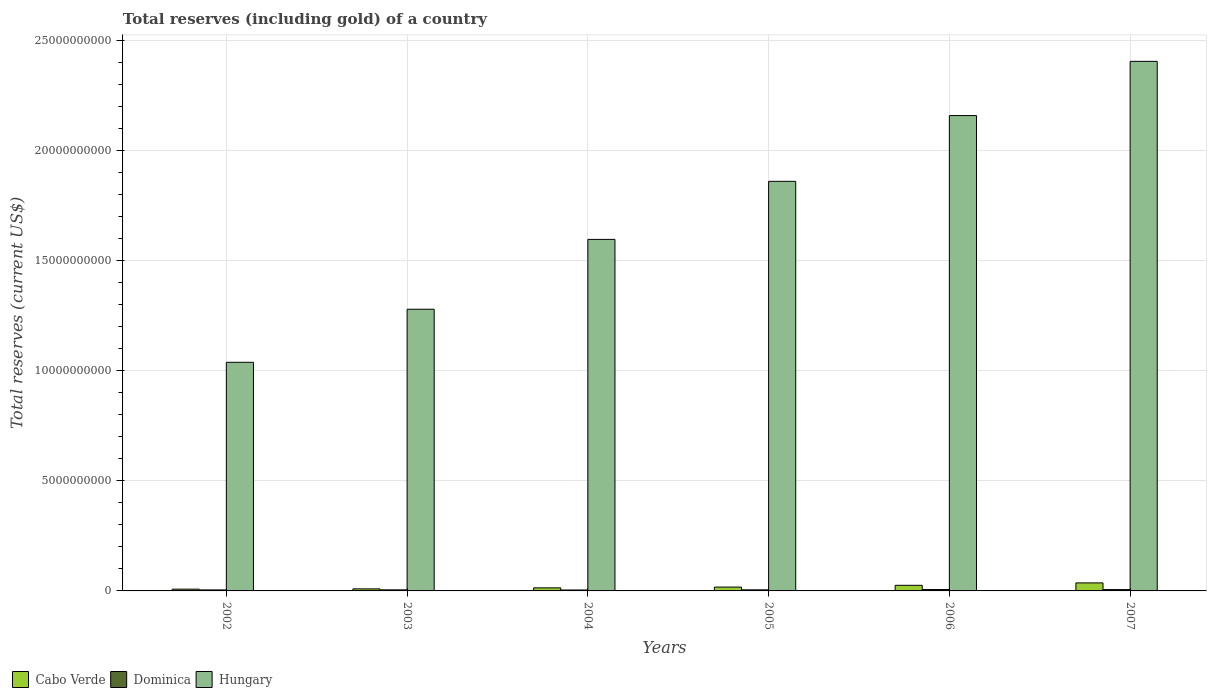Are the number of bars on each tick of the X-axis equal?
Your answer should be very brief. Yes. How many bars are there on the 1st tick from the left?
Offer a very short reply. 3. What is the label of the 4th group of bars from the left?
Ensure brevity in your answer.  2005. What is the total reserves (including gold) in Dominica in 2006?
Keep it short and to the point. 6.30e+07. Across all years, what is the maximum total reserves (including gold) in Dominica?
Your answer should be compact. 6.30e+07. Across all years, what is the minimum total reserves (including gold) in Dominica?
Make the answer very short. 4.23e+07. What is the total total reserves (including gold) in Dominica in the graph?
Offer a very short reply. 3.08e+08. What is the difference between the total reserves (including gold) in Dominica in 2002 and that in 2005?
Make the answer very short. -3.67e+06. What is the difference between the total reserves (including gold) in Cabo Verde in 2005 and the total reserves (including gold) in Dominica in 2002?
Offer a terse response. 1.28e+08. What is the average total reserves (including gold) in Cabo Verde per year?
Make the answer very short. 1.84e+08. In the year 2002, what is the difference between the total reserves (including gold) in Cabo Verde and total reserves (including gold) in Hungary?
Your response must be concise. -1.03e+1. What is the ratio of the total reserves (including gold) in Dominica in 2002 to that in 2005?
Ensure brevity in your answer.  0.93. Is the total reserves (including gold) in Dominica in 2002 less than that in 2005?
Your response must be concise. Yes. What is the difference between the highest and the second highest total reserves (including gold) in Cabo Verde?
Make the answer very short. 1.10e+08. What is the difference between the highest and the lowest total reserves (including gold) in Dominica?
Give a very brief answer. 2.07e+07. Is the sum of the total reserves (including gold) in Cabo Verde in 2002 and 2005 greater than the maximum total reserves (including gold) in Hungary across all years?
Keep it short and to the point. No. What does the 3rd bar from the left in 2005 represents?
Offer a very short reply. Hungary. What does the 2nd bar from the right in 2002 represents?
Keep it short and to the point. Dominica. Is it the case that in every year, the sum of the total reserves (including gold) in Cabo Verde and total reserves (including gold) in Hungary is greater than the total reserves (including gold) in Dominica?
Provide a short and direct response. Yes. How many bars are there?
Make the answer very short. 18. Are all the bars in the graph horizontal?
Offer a terse response. No. Are the values on the major ticks of Y-axis written in scientific E-notation?
Make the answer very short. No. How are the legend labels stacked?
Offer a very short reply. Horizontal. What is the title of the graph?
Give a very brief answer. Total reserves (including gold) of a country. What is the label or title of the X-axis?
Give a very brief answer. Years. What is the label or title of the Y-axis?
Make the answer very short. Total reserves (current US$). What is the Total reserves (current US$) in Cabo Verde in 2002?
Provide a short and direct response. 7.98e+07. What is the Total reserves (current US$) in Dominica in 2002?
Provide a short and direct response. 4.55e+07. What is the Total reserves (current US$) in Hungary in 2002?
Offer a very short reply. 1.04e+1. What is the Total reserves (current US$) in Cabo Verde in 2003?
Your answer should be very brief. 9.36e+07. What is the Total reserves (current US$) of Dominica in 2003?
Your answer should be compact. 4.77e+07. What is the Total reserves (current US$) of Hungary in 2003?
Provide a short and direct response. 1.28e+1. What is the Total reserves (current US$) of Cabo Verde in 2004?
Offer a terse response. 1.40e+08. What is the Total reserves (current US$) of Dominica in 2004?
Offer a very short reply. 4.23e+07. What is the Total reserves (current US$) of Hungary in 2004?
Your answer should be very brief. 1.60e+1. What is the Total reserves (current US$) in Cabo Verde in 2005?
Provide a short and direct response. 1.74e+08. What is the Total reserves (current US$) in Dominica in 2005?
Provide a short and direct response. 4.92e+07. What is the Total reserves (current US$) in Hungary in 2005?
Give a very brief answer. 1.86e+1. What is the Total reserves (current US$) in Cabo Verde in 2006?
Offer a terse response. 2.54e+08. What is the Total reserves (current US$) in Dominica in 2006?
Offer a very short reply. 6.30e+07. What is the Total reserves (current US$) of Hungary in 2006?
Ensure brevity in your answer.  2.16e+1. What is the Total reserves (current US$) in Cabo Verde in 2007?
Your response must be concise. 3.64e+08. What is the Total reserves (current US$) in Dominica in 2007?
Make the answer very short. 6.05e+07. What is the Total reserves (current US$) in Hungary in 2007?
Your answer should be compact. 2.41e+1. Across all years, what is the maximum Total reserves (current US$) of Cabo Verde?
Your response must be concise. 3.64e+08. Across all years, what is the maximum Total reserves (current US$) in Dominica?
Provide a succinct answer. 6.30e+07. Across all years, what is the maximum Total reserves (current US$) of Hungary?
Your answer should be compact. 2.41e+1. Across all years, what is the minimum Total reserves (current US$) of Cabo Verde?
Give a very brief answer. 7.98e+07. Across all years, what is the minimum Total reserves (current US$) in Dominica?
Make the answer very short. 4.23e+07. Across all years, what is the minimum Total reserves (current US$) in Hungary?
Your answer should be very brief. 1.04e+1. What is the total Total reserves (current US$) of Cabo Verde in the graph?
Make the answer very short. 1.11e+09. What is the total Total reserves (current US$) in Dominica in the graph?
Give a very brief answer. 3.08e+08. What is the total Total reserves (current US$) in Hungary in the graph?
Your answer should be compact. 1.03e+11. What is the difference between the Total reserves (current US$) in Cabo Verde in 2002 and that in 2003?
Provide a short and direct response. -1.38e+07. What is the difference between the Total reserves (current US$) of Dominica in 2002 and that in 2003?
Keep it short and to the point. -2.24e+06. What is the difference between the Total reserves (current US$) in Hungary in 2002 and that in 2003?
Offer a terse response. -2.41e+09. What is the difference between the Total reserves (current US$) in Cabo Verde in 2002 and that in 2004?
Ensure brevity in your answer.  -5.97e+07. What is the difference between the Total reserves (current US$) in Dominica in 2002 and that in 2004?
Make the answer very short. 3.18e+06. What is the difference between the Total reserves (current US$) of Hungary in 2002 and that in 2004?
Keep it short and to the point. -5.58e+09. What is the difference between the Total reserves (current US$) of Cabo Verde in 2002 and that in 2005?
Your answer should be very brief. -9.42e+07. What is the difference between the Total reserves (current US$) in Dominica in 2002 and that in 2005?
Offer a very short reply. -3.67e+06. What is the difference between the Total reserves (current US$) of Hungary in 2002 and that in 2005?
Ensure brevity in your answer.  -8.22e+09. What is the difference between the Total reserves (current US$) in Cabo Verde in 2002 and that in 2006?
Keep it short and to the point. -1.75e+08. What is the difference between the Total reserves (current US$) in Dominica in 2002 and that in 2006?
Offer a very short reply. -1.75e+07. What is the difference between the Total reserves (current US$) of Hungary in 2002 and that in 2006?
Provide a succinct answer. -1.12e+1. What is the difference between the Total reserves (current US$) of Cabo Verde in 2002 and that in 2007?
Offer a terse response. -2.85e+08. What is the difference between the Total reserves (current US$) in Dominica in 2002 and that in 2007?
Give a very brief answer. -1.50e+07. What is the difference between the Total reserves (current US$) of Hungary in 2002 and that in 2007?
Give a very brief answer. -1.37e+1. What is the difference between the Total reserves (current US$) of Cabo Verde in 2003 and that in 2004?
Provide a succinct answer. -4.59e+07. What is the difference between the Total reserves (current US$) in Dominica in 2003 and that in 2004?
Provide a short and direct response. 5.41e+06. What is the difference between the Total reserves (current US$) in Hungary in 2003 and that in 2004?
Give a very brief answer. -3.17e+09. What is the difference between the Total reserves (current US$) of Cabo Verde in 2003 and that in 2005?
Ensure brevity in your answer.  -8.04e+07. What is the difference between the Total reserves (current US$) of Dominica in 2003 and that in 2005?
Your response must be concise. -1.44e+06. What is the difference between the Total reserves (current US$) of Hungary in 2003 and that in 2005?
Your answer should be very brief. -5.81e+09. What is the difference between the Total reserves (current US$) of Cabo Verde in 2003 and that in 2006?
Ensure brevity in your answer.  -1.61e+08. What is the difference between the Total reserves (current US$) of Dominica in 2003 and that in 2006?
Your response must be concise. -1.53e+07. What is the difference between the Total reserves (current US$) in Hungary in 2003 and that in 2006?
Your answer should be very brief. -8.80e+09. What is the difference between the Total reserves (current US$) of Cabo Verde in 2003 and that in 2007?
Your answer should be compact. -2.71e+08. What is the difference between the Total reserves (current US$) of Dominica in 2003 and that in 2007?
Keep it short and to the point. -1.28e+07. What is the difference between the Total reserves (current US$) in Hungary in 2003 and that in 2007?
Ensure brevity in your answer.  -1.13e+1. What is the difference between the Total reserves (current US$) in Cabo Verde in 2004 and that in 2005?
Make the answer very short. -3.44e+07. What is the difference between the Total reserves (current US$) in Dominica in 2004 and that in 2005?
Your answer should be compact. -6.85e+06. What is the difference between the Total reserves (current US$) of Hungary in 2004 and that in 2005?
Your response must be concise. -2.64e+09. What is the difference between the Total reserves (current US$) of Cabo Verde in 2004 and that in 2006?
Make the answer very short. -1.15e+08. What is the difference between the Total reserves (current US$) of Dominica in 2004 and that in 2006?
Offer a terse response. -2.07e+07. What is the difference between the Total reserves (current US$) in Hungary in 2004 and that in 2006?
Provide a short and direct response. -5.62e+09. What is the difference between the Total reserves (current US$) of Cabo Verde in 2004 and that in 2007?
Your answer should be compact. -2.25e+08. What is the difference between the Total reserves (current US$) in Dominica in 2004 and that in 2007?
Provide a succinct answer. -1.82e+07. What is the difference between the Total reserves (current US$) in Hungary in 2004 and that in 2007?
Ensure brevity in your answer.  -8.09e+09. What is the difference between the Total reserves (current US$) of Cabo Verde in 2005 and that in 2006?
Keep it short and to the point. -8.05e+07. What is the difference between the Total reserves (current US$) in Dominica in 2005 and that in 2006?
Give a very brief answer. -1.39e+07. What is the difference between the Total reserves (current US$) of Hungary in 2005 and that in 2006?
Provide a short and direct response. -2.99e+09. What is the difference between the Total reserves (current US$) in Cabo Verde in 2005 and that in 2007?
Provide a short and direct response. -1.90e+08. What is the difference between the Total reserves (current US$) of Dominica in 2005 and that in 2007?
Make the answer very short. -1.13e+07. What is the difference between the Total reserves (current US$) of Hungary in 2005 and that in 2007?
Make the answer very short. -5.45e+09. What is the difference between the Total reserves (current US$) of Cabo Verde in 2006 and that in 2007?
Your response must be concise. -1.10e+08. What is the difference between the Total reserves (current US$) in Dominica in 2006 and that in 2007?
Your answer should be compact. 2.53e+06. What is the difference between the Total reserves (current US$) of Hungary in 2006 and that in 2007?
Offer a terse response. -2.46e+09. What is the difference between the Total reserves (current US$) in Cabo Verde in 2002 and the Total reserves (current US$) in Dominica in 2003?
Keep it short and to the point. 3.21e+07. What is the difference between the Total reserves (current US$) of Cabo Verde in 2002 and the Total reserves (current US$) of Hungary in 2003?
Your response must be concise. -1.27e+1. What is the difference between the Total reserves (current US$) in Dominica in 2002 and the Total reserves (current US$) in Hungary in 2003?
Your answer should be very brief. -1.27e+1. What is the difference between the Total reserves (current US$) in Cabo Verde in 2002 and the Total reserves (current US$) in Dominica in 2004?
Make the answer very short. 3.75e+07. What is the difference between the Total reserves (current US$) in Cabo Verde in 2002 and the Total reserves (current US$) in Hungary in 2004?
Your response must be concise. -1.59e+1. What is the difference between the Total reserves (current US$) of Dominica in 2002 and the Total reserves (current US$) of Hungary in 2004?
Provide a short and direct response. -1.59e+1. What is the difference between the Total reserves (current US$) of Cabo Verde in 2002 and the Total reserves (current US$) of Dominica in 2005?
Offer a very short reply. 3.06e+07. What is the difference between the Total reserves (current US$) in Cabo Verde in 2002 and the Total reserves (current US$) in Hungary in 2005?
Ensure brevity in your answer.  -1.85e+1. What is the difference between the Total reserves (current US$) of Dominica in 2002 and the Total reserves (current US$) of Hungary in 2005?
Offer a very short reply. -1.86e+1. What is the difference between the Total reserves (current US$) of Cabo Verde in 2002 and the Total reserves (current US$) of Dominica in 2006?
Your response must be concise. 1.68e+07. What is the difference between the Total reserves (current US$) in Cabo Verde in 2002 and the Total reserves (current US$) in Hungary in 2006?
Your response must be concise. -2.15e+1. What is the difference between the Total reserves (current US$) of Dominica in 2002 and the Total reserves (current US$) of Hungary in 2006?
Keep it short and to the point. -2.15e+1. What is the difference between the Total reserves (current US$) in Cabo Verde in 2002 and the Total reserves (current US$) in Dominica in 2007?
Your answer should be compact. 1.93e+07. What is the difference between the Total reserves (current US$) in Cabo Verde in 2002 and the Total reserves (current US$) in Hungary in 2007?
Give a very brief answer. -2.40e+1. What is the difference between the Total reserves (current US$) of Dominica in 2002 and the Total reserves (current US$) of Hungary in 2007?
Provide a succinct answer. -2.40e+1. What is the difference between the Total reserves (current US$) of Cabo Verde in 2003 and the Total reserves (current US$) of Dominica in 2004?
Keep it short and to the point. 5.13e+07. What is the difference between the Total reserves (current US$) in Cabo Verde in 2003 and the Total reserves (current US$) in Hungary in 2004?
Keep it short and to the point. -1.59e+1. What is the difference between the Total reserves (current US$) in Dominica in 2003 and the Total reserves (current US$) in Hungary in 2004?
Ensure brevity in your answer.  -1.59e+1. What is the difference between the Total reserves (current US$) of Cabo Verde in 2003 and the Total reserves (current US$) of Dominica in 2005?
Make the answer very short. 4.44e+07. What is the difference between the Total reserves (current US$) of Cabo Verde in 2003 and the Total reserves (current US$) of Hungary in 2005?
Your response must be concise. -1.85e+1. What is the difference between the Total reserves (current US$) of Dominica in 2003 and the Total reserves (current US$) of Hungary in 2005?
Offer a terse response. -1.86e+1. What is the difference between the Total reserves (current US$) in Cabo Verde in 2003 and the Total reserves (current US$) in Dominica in 2006?
Keep it short and to the point. 3.06e+07. What is the difference between the Total reserves (current US$) of Cabo Verde in 2003 and the Total reserves (current US$) of Hungary in 2006?
Ensure brevity in your answer.  -2.15e+1. What is the difference between the Total reserves (current US$) in Dominica in 2003 and the Total reserves (current US$) in Hungary in 2006?
Your answer should be very brief. -2.15e+1. What is the difference between the Total reserves (current US$) in Cabo Verde in 2003 and the Total reserves (current US$) in Dominica in 2007?
Provide a short and direct response. 3.31e+07. What is the difference between the Total reserves (current US$) in Cabo Verde in 2003 and the Total reserves (current US$) in Hungary in 2007?
Your answer should be very brief. -2.40e+1. What is the difference between the Total reserves (current US$) of Dominica in 2003 and the Total reserves (current US$) of Hungary in 2007?
Your answer should be very brief. -2.40e+1. What is the difference between the Total reserves (current US$) of Cabo Verde in 2004 and the Total reserves (current US$) of Dominica in 2005?
Provide a succinct answer. 9.04e+07. What is the difference between the Total reserves (current US$) of Cabo Verde in 2004 and the Total reserves (current US$) of Hungary in 2005?
Ensure brevity in your answer.  -1.85e+1. What is the difference between the Total reserves (current US$) of Dominica in 2004 and the Total reserves (current US$) of Hungary in 2005?
Give a very brief answer. -1.86e+1. What is the difference between the Total reserves (current US$) in Cabo Verde in 2004 and the Total reserves (current US$) in Dominica in 2006?
Your answer should be very brief. 7.65e+07. What is the difference between the Total reserves (current US$) of Cabo Verde in 2004 and the Total reserves (current US$) of Hungary in 2006?
Offer a terse response. -2.15e+1. What is the difference between the Total reserves (current US$) in Dominica in 2004 and the Total reserves (current US$) in Hungary in 2006?
Offer a terse response. -2.15e+1. What is the difference between the Total reserves (current US$) of Cabo Verde in 2004 and the Total reserves (current US$) of Dominica in 2007?
Give a very brief answer. 7.90e+07. What is the difference between the Total reserves (current US$) in Cabo Verde in 2004 and the Total reserves (current US$) in Hungary in 2007?
Keep it short and to the point. -2.39e+1. What is the difference between the Total reserves (current US$) in Dominica in 2004 and the Total reserves (current US$) in Hungary in 2007?
Keep it short and to the point. -2.40e+1. What is the difference between the Total reserves (current US$) of Cabo Verde in 2005 and the Total reserves (current US$) of Dominica in 2006?
Offer a terse response. 1.11e+08. What is the difference between the Total reserves (current US$) in Cabo Verde in 2005 and the Total reserves (current US$) in Hungary in 2006?
Ensure brevity in your answer.  -2.14e+1. What is the difference between the Total reserves (current US$) in Dominica in 2005 and the Total reserves (current US$) in Hungary in 2006?
Offer a very short reply. -2.15e+1. What is the difference between the Total reserves (current US$) in Cabo Verde in 2005 and the Total reserves (current US$) in Dominica in 2007?
Offer a terse response. 1.13e+08. What is the difference between the Total reserves (current US$) in Cabo Verde in 2005 and the Total reserves (current US$) in Hungary in 2007?
Your answer should be very brief. -2.39e+1. What is the difference between the Total reserves (current US$) in Dominica in 2005 and the Total reserves (current US$) in Hungary in 2007?
Provide a short and direct response. -2.40e+1. What is the difference between the Total reserves (current US$) of Cabo Verde in 2006 and the Total reserves (current US$) of Dominica in 2007?
Make the answer very short. 1.94e+08. What is the difference between the Total reserves (current US$) in Cabo Verde in 2006 and the Total reserves (current US$) in Hungary in 2007?
Your response must be concise. -2.38e+1. What is the difference between the Total reserves (current US$) of Dominica in 2006 and the Total reserves (current US$) of Hungary in 2007?
Your answer should be compact. -2.40e+1. What is the average Total reserves (current US$) of Cabo Verde per year?
Offer a very short reply. 1.84e+08. What is the average Total reserves (current US$) of Dominica per year?
Provide a succinct answer. 5.14e+07. What is the average Total reserves (current US$) in Hungary per year?
Offer a very short reply. 1.72e+1. In the year 2002, what is the difference between the Total reserves (current US$) of Cabo Verde and Total reserves (current US$) of Dominica?
Keep it short and to the point. 3.43e+07. In the year 2002, what is the difference between the Total reserves (current US$) of Cabo Verde and Total reserves (current US$) of Hungary?
Your answer should be very brief. -1.03e+1. In the year 2002, what is the difference between the Total reserves (current US$) in Dominica and Total reserves (current US$) in Hungary?
Offer a very short reply. -1.03e+1. In the year 2003, what is the difference between the Total reserves (current US$) of Cabo Verde and Total reserves (current US$) of Dominica?
Make the answer very short. 4.59e+07. In the year 2003, what is the difference between the Total reserves (current US$) of Cabo Verde and Total reserves (current US$) of Hungary?
Ensure brevity in your answer.  -1.27e+1. In the year 2003, what is the difference between the Total reserves (current US$) in Dominica and Total reserves (current US$) in Hungary?
Your response must be concise. -1.27e+1. In the year 2004, what is the difference between the Total reserves (current US$) of Cabo Verde and Total reserves (current US$) of Dominica?
Give a very brief answer. 9.72e+07. In the year 2004, what is the difference between the Total reserves (current US$) of Cabo Verde and Total reserves (current US$) of Hungary?
Offer a terse response. -1.58e+1. In the year 2004, what is the difference between the Total reserves (current US$) of Dominica and Total reserves (current US$) of Hungary?
Make the answer very short. -1.59e+1. In the year 2005, what is the difference between the Total reserves (current US$) of Cabo Verde and Total reserves (current US$) of Dominica?
Provide a short and direct response. 1.25e+08. In the year 2005, what is the difference between the Total reserves (current US$) of Cabo Verde and Total reserves (current US$) of Hungary?
Offer a very short reply. -1.84e+1. In the year 2005, what is the difference between the Total reserves (current US$) in Dominica and Total reserves (current US$) in Hungary?
Offer a terse response. -1.86e+1. In the year 2006, what is the difference between the Total reserves (current US$) of Cabo Verde and Total reserves (current US$) of Dominica?
Make the answer very short. 1.91e+08. In the year 2006, what is the difference between the Total reserves (current US$) of Cabo Verde and Total reserves (current US$) of Hungary?
Your answer should be compact. -2.13e+1. In the year 2006, what is the difference between the Total reserves (current US$) in Dominica and Total reserves (current US$) in Hungary?
Provide a short and direct response. -2.15e+1. In the year 2007, what is the difference between the Total reserves (current US$) in Cabo Verde and Total reserves (current US$) in Dominica?
Your answer should be very brief. 3.04e+08. In the year 2007, what is the difference between the Total reserves (current US$) of Cabo Verde and Total reserves (current US$) of Hungary?
Your answer should be compact. -2.37e+1. In the year 2007, what is the difference between the Total reserves (current US$) in Dominica and Total reserves (current US$) in Hungary?
Offer a very short reply. -2.40e+1. What is the ratio of the Total reserves (current US$) of Cabo Verde in 2002 to that in 2003?
Your answer should be compact. 0.85. What is the ratio of the Total reserves (current US$) in Dominica in 2002 to that in 2003?
Keep it short and to the point. 0.95. What is the ratio of the Total reserves (current US$) of Hungary in 2002 to that in 2003?
Offer a terse response. 0.81. What is the ratio of the Total reserves (current US$) in Cabo Verde in 2002 to that in 2004?
Provide a short and direct response. 0.57. What is the ratio of the Total reserves (current US$) of Dominica in 2002 to that in 2004?
Ensure brevity in your answer.  1.07. What is the ratio of the Total reserves (current US$) in Hungary in 2002 to that in 2004?
Your answer should be very brief. 0.65. What is the ratio of the Total reserves (current US$) of Cabo Verde in 2002 to that in 2005?
Provide a succinct answer. 0.46. What is the ratio of the Total reserves (current US$) of Dominica in 2002 to that in 2005?
Provide a succinct answer. 0.93. What is the ratio of the Total reserves (current US$) in Hungary in 2002 to that in 2005?
Make the answer very short. 0.56. What is the ratio of the Total reserves (current US$) of Cabo Verde in 2002 to that in 2006?
Ensure brevity in your answer.  0.31. What is the ratio of the Total reserves (current US$) of Dominica in 2002 to that in 2006?
Offer a terse response. 0.72. What is the ratio of the Total reserves (current US$) in Hungary in 2002 to that in 2006?
Make the answer very short. 0.48. What is the ratio of the Total reserves (current US$) in Cabo Verde in 2002 to that in 2007?
Provide a short and direct response. 0.22. What is the ratio of the Total reserves (current US$) in Dominica in 2002 to that in 2007?
Give a very brief answer. 0.75. What is the ratio of the Total reserves (current US$) of Hungary in 2002 to that in 2007?
Your response must be concise. 0.43. What is the ratio of the Total reserves (current US$) in Cabo Verde in 2003 to that in 2004?
Provide a short and direct response. 0.67. What is the ratio of the Total reserves (current US$) of Dominica in 2003 to that in 2004?
Give a very brief answer. 1.13. What is the ratio of the Total reserves (current US$) in Hungary in 2003 to that in 2004?
Offer a terse response. 0.8. What is the ratio of the Total reserves (current US$) in Cabo Verde in 2003 to that in 2005?
Offer a terse response. 0.54. What is the ratio of the Total reserves (current US$) in Dominica in 2003 to that in 2005?
Offer a very short reply. 0.97. What is the ratio of the Total reserves (current US$) in Hungary in 2003 to that in 2005?
Offer a very short reply. 0.69. What is the ratio of the Total reserves (current US$) in Cabo Verde in 2003 to that in 2006?
Give a very brief answer. 0.37. What is the ratio of the Total reserves (current US$) in Dominica in 2003 to that in 2006?
Provide a succinct answer. 0.76. What is the ratio of the Total reserves (current US$) in Hungary in 2003 to that in 2006?
Provide a succinct answer. 0.59. What is the ratio of the Total reserves (current US$) of Cabo Verde in 2003 to that in 2007?
Make the answer very short. 0.26. What is the ratio of the Total reserves (current US$) in Dominica in 2003 to that in 2007?
Your answer should be compact. 0.79. What is the ratio of the Total reserves (current US$) in Hungary in 2003 to that in 2007?
Offer a very short reply. 0.53. What is the ratio of the Total reserves (current US$) in Cabo Verde in 2004 to that in 2005?
Give a very brief answer. 0.8. What is the ratio of the Total reserves (current US$) of Dominica in 2004 to that in 2005?
Keep it short and to the point. 0.86. What is the ratio of the Total reserves (current US$) in Hungary in 2004 to that in 2005?
Your response must be concise. 0.86. What is the ratio of the Total reserves (current US$) in Cabo Verde in 2004 to that in 2006?
Your response must be concise. 0.55. What is the ratio of the Total reserves (current US$) of Dominica in 2004 to that in 2006?
Ensure brevity in your answer.  0.67. What is the ratio of the Total reserves (current US$) in Hungary in 2004 to that in 2006?
Ensure brevity in your answer.  0.74. What is the ratio of the Total reserves (current US$) in Cabo Verde in 2004 to that in 2007?
Make the answer very short. 0.38. What is the ratio of the Total reserves (current US$) in Dominica in 2004 to that in 2007?
Make the answer very short. 0.7. What is the ratio of the Total reserves (current US$) in Hungary in 2004 to that in 2007?
Offer a very short reply. 0.66. What is the ratio of the Total reserves (current US$) of Cabo Verde in 2005 to that in 2006?
Offer a very short reply. 0.68. What is the ratio of the Total reserves (current US$) in Dominica in 2005 to that in 2006?
Your answer should be compact. 0.78. What is the ratio of the Total reserves (current US$) of Hungary in 2005 to that in 2006?
Provide a succinct answer. 0.86. What is the ratio of the Total reserves (current US$) of Cabo Verde in 2005 to that in 2007?
Offer a very short reply. 0.48. What is the ratio of the Total reserves (current US$) in Dominica in 2005 to that in 2007?
Provide a succinct answer. 0.81. What is the ratio of the Total reserves (current US$) of Hungary in 2005 to that in 2007?
Your answer should be compact. 0.77. What is the ratio of the Total reserves (current US$) in Cabo Verde in 2006 to that in 2007?
Ensure brevity in your answer.  0.7. What is the ratio of the Total reserves (current US$) in Dominica in 2006 to that in 2007?
Make the answer very short. 1.04. What is the ratio of the Total reserves (current US$) of Hungary in 2006 to that in 2007?
Provide a short and direct response. 0.9. What is the difference between the highest and the second highest Total reserves (current US$) in Cabo Verde?
Offer a terse response. 1.10e+08. What is the difference between the highest and the second highest Total reserves (current US$) of Dominica?
Your answer should be compact. 2.53e+06. What is the difference between the highest and the second highest Total reserves (current US$) in Hungary?
Keep it short and to the point. 2.46e+09. What is the difference between the highest and the lowest Total reserves (current US$) in Cabo Verde?
Keep it short and to the point. 2.85e+08. What is the difference between the highest and the lowest Total reserves (current US$) in Dominica?
Provide a short and direct response. 2.07e+07. What is the difference between the highest and the lowest Total reserves (current US$) of Hungary?
Give a very brief answer. 1.37e+1. 